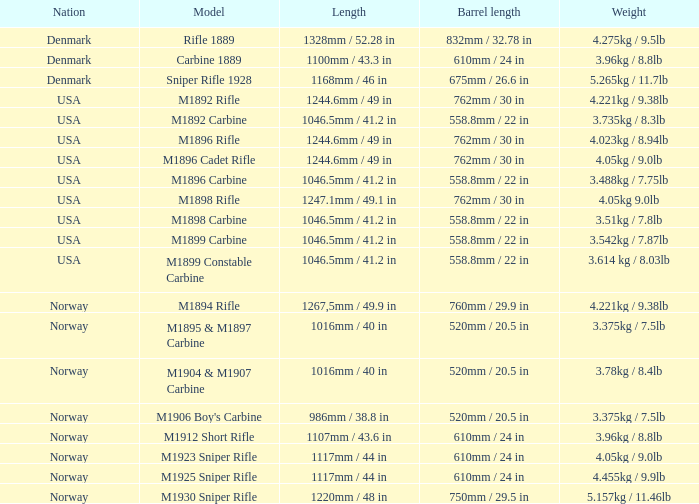What does it weigh, when the distance is 1168mm / 46 in? 5.265kg / 11.7lb. 